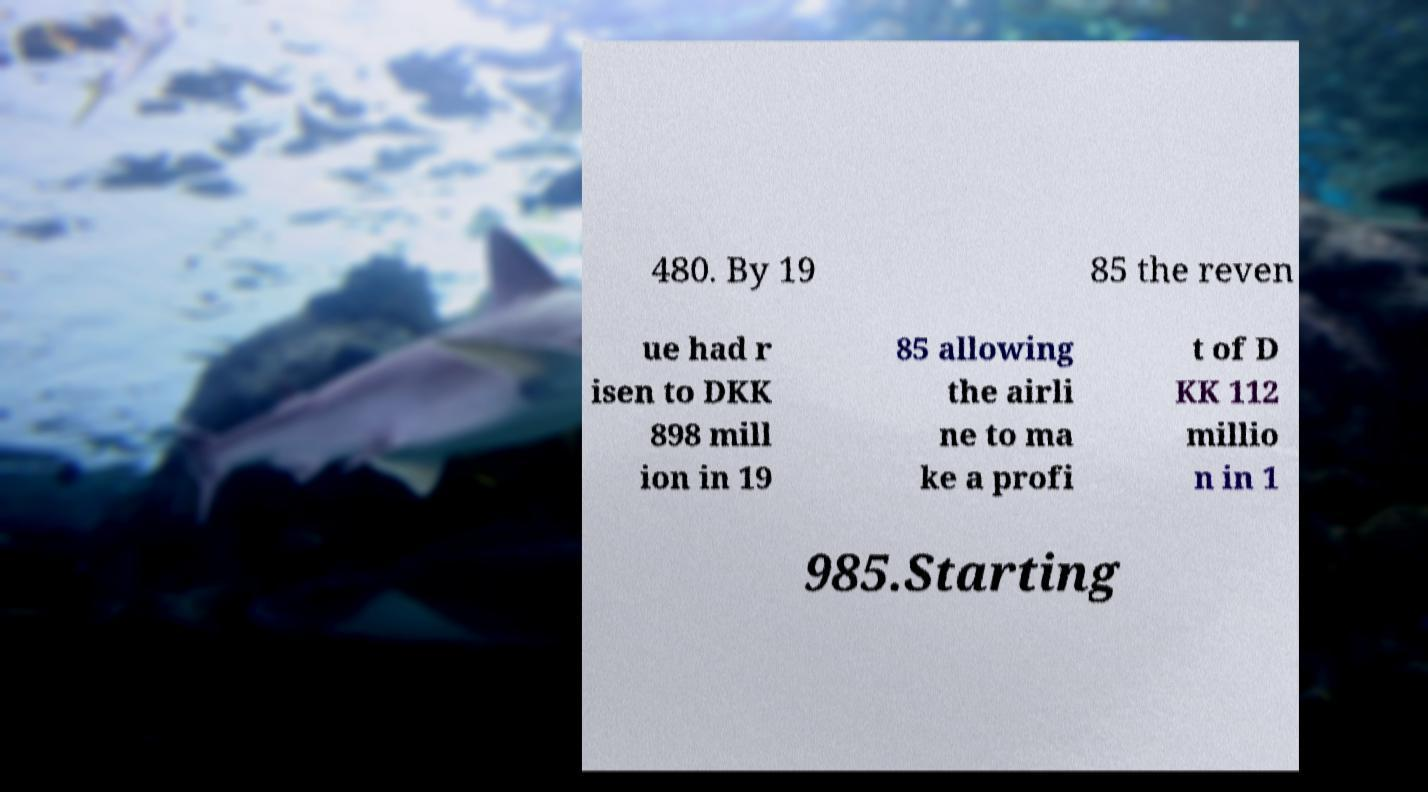Please identify and transcribe the text found in this image. 480. By 19 85 the reven ue had r isen to DKK 898 mill ion in 19 85 allowing the airli ne to ma ke a profi t of D KK 112 millio n in 1 985.Starting 